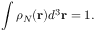Convert formula to latex. <formula><loc_0><loc_0><loc_500><loc_500>\int \rho _ { N } ( r ) d ^ { 3 } r = 1 .</formula> 